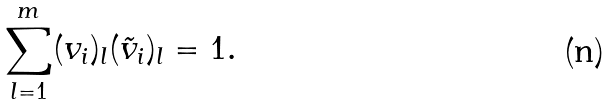Convert formula to latex. <formula><loc_0><loc_0><loc_500><loc_500>\sum _ { l = 1 } ^ { m } ( { v } _ { i } ) _ { l } ( { \tilde { v } } _ { i } ) _ { l } = 1 .</formula> 